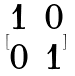Convert formula to latex. <formula><loc_0><loc_0><loc_500><loc_500>[ \begin{matrix} 1 & 0 \\ 0 & 1 \end{matrix} ]</formula> 